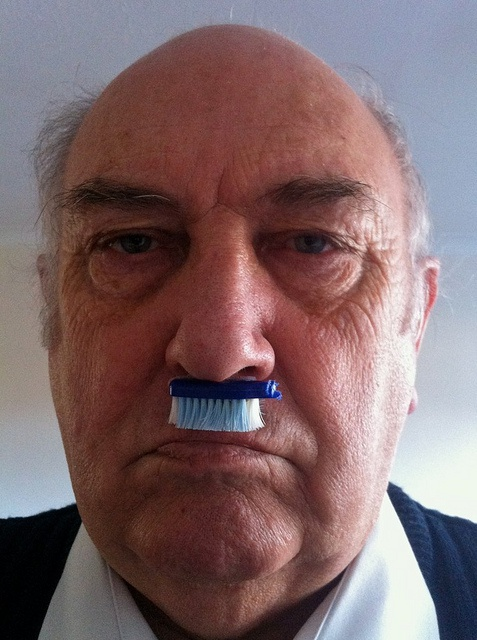Describe the objects in this image and their specific colors. I can see people in darkgray, maroon, brown, black, and gray tones and toothbrush in darkgray, black, gray, blue, and navy tones in this image. 